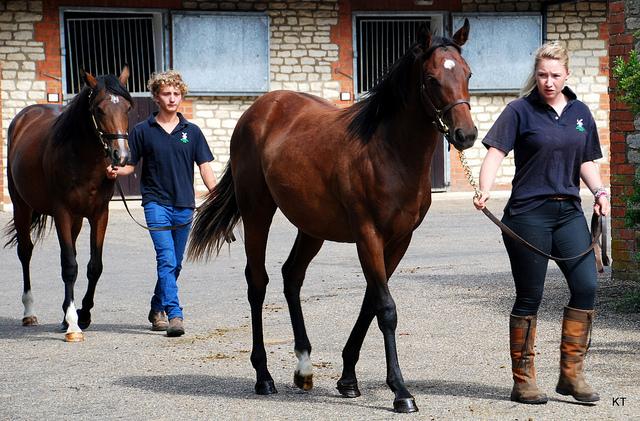What color is the first horse?
Give a very brief answer. Brown. How many horses are looking at the camera?
Quick response, please. 0. How many horses are there?
Answer briefly. 2. How many people are there?
Answer briefly. 2. 